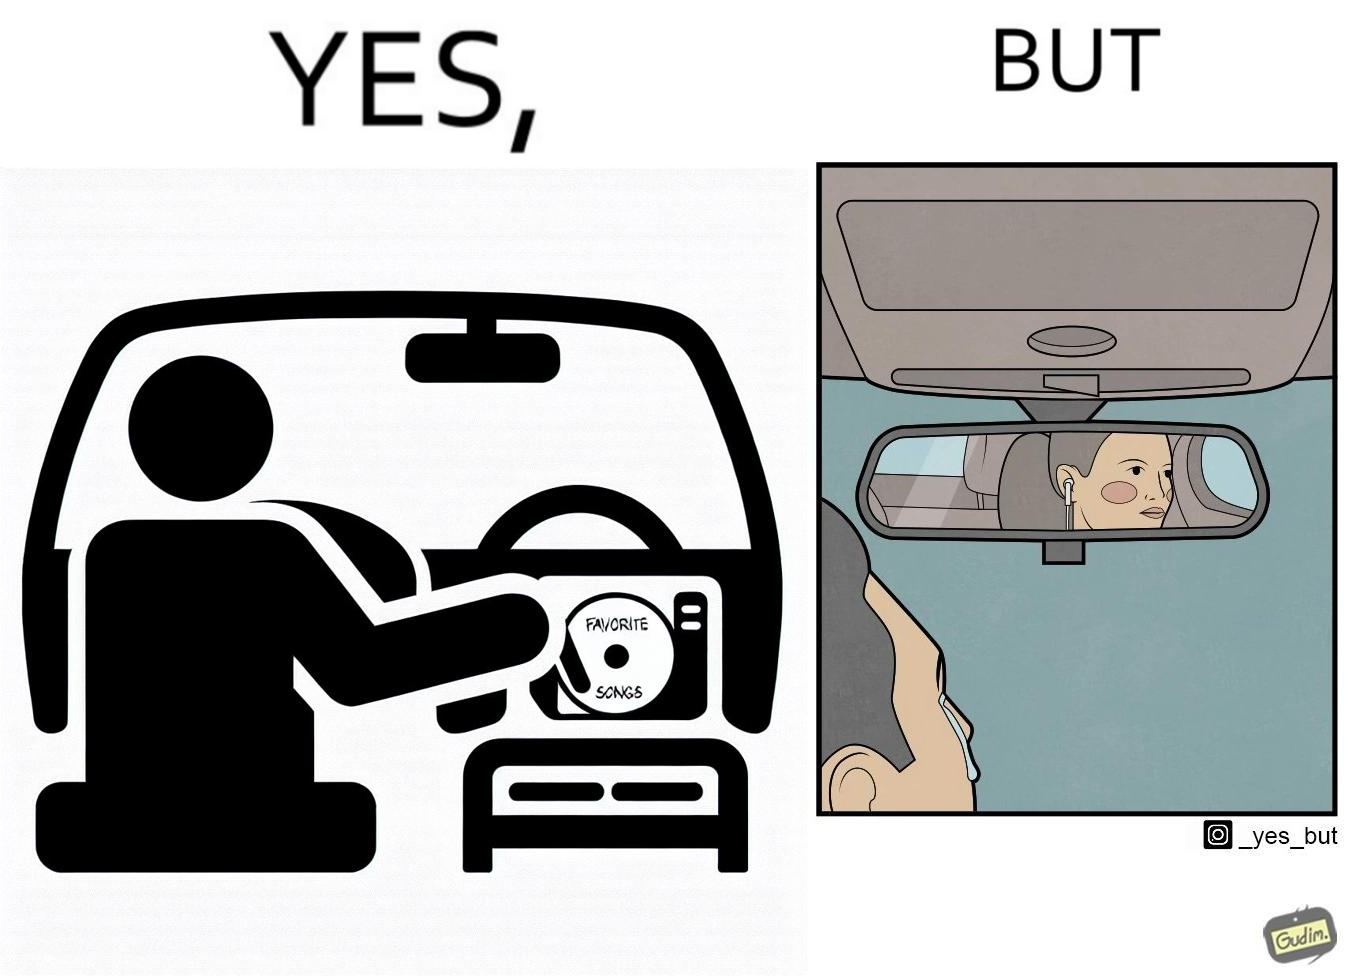Explain why this image is satirical. The image is funny, as the driver of the car inserts a CD named "Favorite Songs" into the CD player for the passenger, but the driver is sad on seeing the passenger in the back seat listening to something else on earphones instead. 